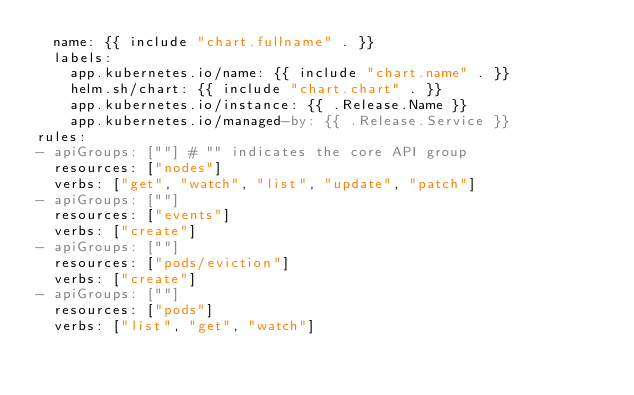Convert code to text. <code><loc_0><loc_0><loc_500><loc_500><_YAML_>  name: {{ include "chart.fullname" . }}
  labels:
    app.kubernetes.io/name: {{ include "chart.name" . }}
    helm.sh/chart: {{ include "chart.chart" . }}
    app.kubernetes.io/instance: {{ .Release.Name }}
    app.kubernetes.io/managed-by: {{ .Release.Service }}
rules:
- apiGroups: [""] # "" indicates the core API group
  resources: ["nodes"]
  verbs: ["get", "watch", "list", "update", "patch"]
- apiGroups: [""]
  resources: ["events"]
  verbs: ["create"]
- apiGroups: [""]
  resources: ["pods/eviction"]
  verbs: ["create"]
- apiGroups: [""]
  resources: ["pods"]
  verbs: ["list", "get", "watch"]
</code> 